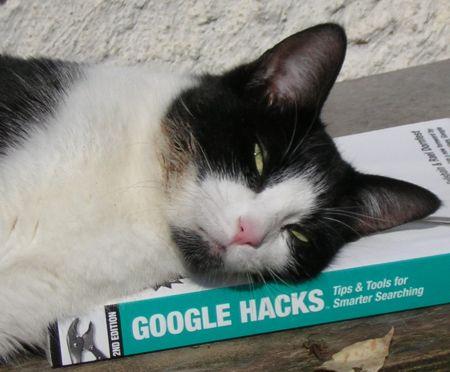What will the book help you learn to do?
Concise answer only. Google hacks. Was the cat reading the book?
Answer briefly. No. What color are the cats eyes?
Give a very brief answer. Green. 